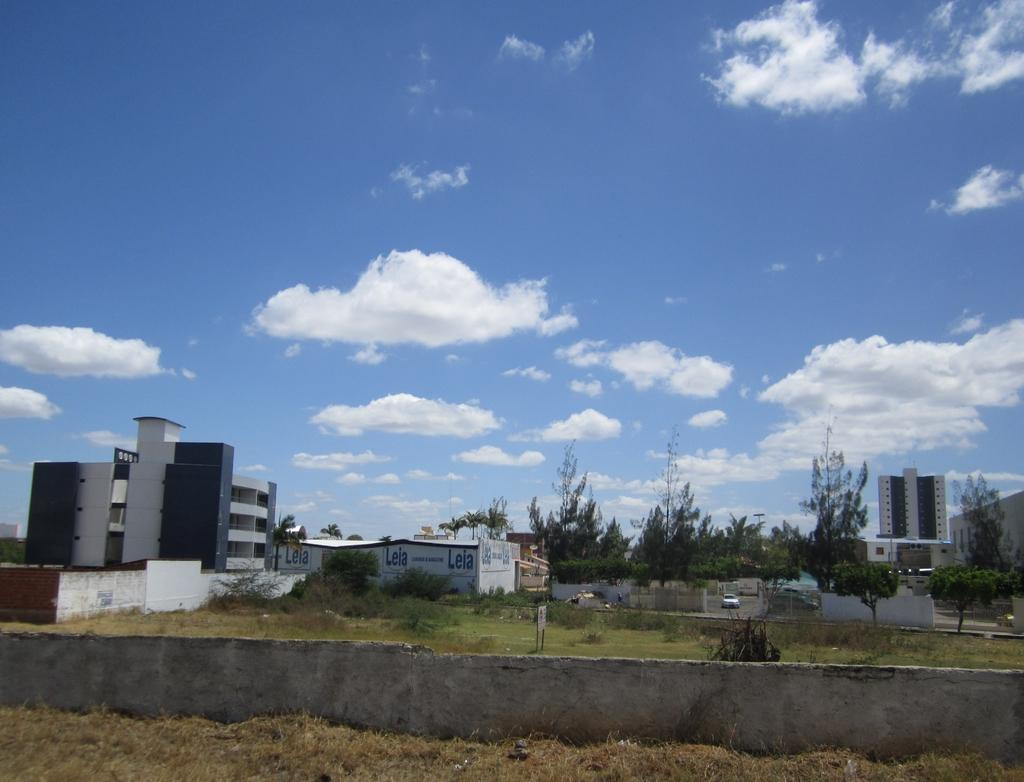What type of structures can be seen in the image? There are buildings in the image. What natural elements are present in the image? There are trees, grass, and a plant visible in the image. What man-made object can be seen in the image? There is a wall in the image. What is the condition of the sky in the image? The sky is cloudy and pale blue in the image. What mode of transportation is on the road in the image? There is a vehicle on the road in the image. What additional object can be seen in the image? There is a board in the image. Can you tell me how many animals from the zoo are visible in the image? There is no zoo or animals from a zoo present in the image. What type of powder is being used to cover the shame of the people in the image? There is no indication of shame or powder in the image. 